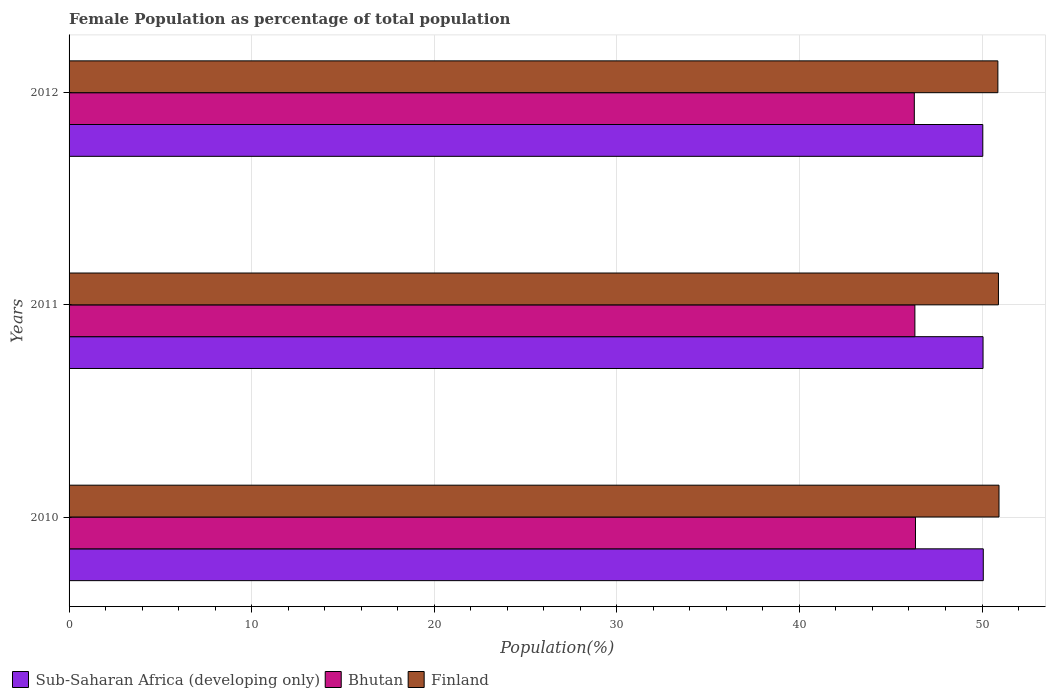How many groups of bars are there?
Offer a terse response. 3. Are the number of bars per tick equal to the number of legend labels?
Your response must be concise. Yes. Are the number of bars on each tick of the Y-axis equal?
Your answer should be compact. Yes. How many bars are there on the 2nd tick from the top?
Offer a terse response. 3. How many bars are there on the 1st tick from the bottom?
Offer a very short reply. 3. What is the label of the 3rd group of bars from the top?
Keep it short and to the point. 2010. What is the female population in in Bhutan in 2011?
Ensure brevity in your answer.  46.32. Across all years, what is the maximum female population in in Finland?
Provide a short and direct response. 50.93. Across all years, what is the minimum female population in in Finland?
Offer a terse response. 50.87. What is the total female population in in Bhutan in the graph?
Your response must be concise. 138.97. What is the difference between the female population in in Sub-Saharan Africa (developing only) in 2011 and that in 2012?
Provide a short and direct response. 0.01. What is the difference between the female population in in Finland in 2011 and the female population in in Sub-Saharan Africa (developing only) in 2012?
Ensure brevity in your answer.  0.86. What is the average female population in in Bhutan per year?
Provide a short and direct response. 46.32. In the year 2010, what is the difference between the female population in in Sub-Saharan Africa (developing only) and female population in in Finland?
Give a very brief answer. -0.86. In how many years, is the female population in in Bhutan greater than 16 %?
Give a very brief answer. 3. What is the ratio of the female population in in Finland in 2011 to that in 2012?
Make the answer very short. 1. Is the female population in in Sub-Saharan Africa (developing only) in 2011 less than that in 2012?
Keep it short and to the point. No. What is the difference between the highest and the second highest female population in in Bhutan?
Ensure brevity in your answer.  0.03. What is the difference between the highest and the lowest female population in in Bhutan?
Your response must be concise. 0.06. Is the sum of the female population in in Bhutan in 2010 and 2012 greater than the maximum female population in in Finland across all years?
Provide a succinct answer. Yes. What does the 3rd bar from the top in 2012 represents?
Your answer should be compact. Sub-Saharan Africa (developing only). What does the 1st bar from the bottom in 2010 represents?
Offer a very short reply. Sub-Saharan Africa (developing only). Is it the case that in every year, the sum of the female population in in Finland and female population in in Sub-Saharan Africa (developing only) is greater than the female population in in Bhutan?
Your answer should be very brief. Yes. Are all the bars in the graph horizontal?
Make the answer very short. Yes. What is the difference between two consecutive major ticks on the X-axis?
Your answer should be compact. 10. Does the graph contain any zero values?
Provide a short and direct response. No. Where does the legend appear in the graph?
Provide a succinct answer. Bottom left. What is the title of the graph?
Keep it short and to the point. Female Population as percentage of total population. What is the label or title of the X-axis?
Your answer should be compact. Population(%). What is the label or title of the Y-axis?
Your answer should be very brief. Years. What is the Population(%) in Sub-Saharan Africa (developing only) in 2010?
Offer a terse response. 50.07. What is the Population(%) of Bhutan in 2010?
Offer a very short reply. 46.36. What is the Population(%) of Finland in 2010?
Offer a terse response. 50.93. What is the Population(%) in Sub-Saharan Africa (developing only) in 2011?
Give a very brief answer. 50.06. What is the Population(%) in Bhutan in 2011?
Your answer should be very brief. 46.32. What is the Population(%) of Finland in 2011?
Ensure brevity in your answer.  50.9. What is the Population(%) in Sub-Saharan Africa (developing only) in 2012?
Your response must be concise. 50.04. What is the Population(%) of Bhutan in 2012?
Your answer should be very brief. 46.29. What is the Population(%) in Finland in 2012?
Keep it short and to the point. 50.87. Across all years, what is the maximum Population(%) of Sub-Saharan Africa (developing only)?
Offer a very short reply. 50.07. Across all years, what is the maximum Population(%) of Bhutan?
Provide a succinct answer. 46.36. Across all years, what is the maximum Population(%) of Finland?
Your answer should be very brief. 50.93. Across all years, what is the minimum Population(%) in Sub-Saharan Africa (developing only)?
Your response must be concise. 50.04. Across all years, what is the minimum Population(%) of Bhutan?
Offer a very short reply. 46.29. Across all years, what is the minimum Population(%) in Finland?
Offer a very short reply. 50.87. What is the total Population(%) of Sub-Saharan Africa (developing only) in the graph?
Provide a succinct answer. 150.17. What is the total Population(%) of Bhutan in the graph?
Give a very brief answer. 138.97. What is the total Population(%) in Finland in the graph?
Offer a very short reply. 152.7. What is the difference between the Population(%) in Sub-Saharan Africa (developing only) in 2010 and that in 2011?
Offer a terse response. 0.01. What is the difference between the Population(%) of Bhutan in 2010 and that in 2011?
Your answer should be very brief. 0.03. What is the difference between the Population(%) of Finland in 2010 and that in 2011?
Your answer should be very brief. 0.03. What is the difference between the Population(%) of Sub-Saharan Africa (developing only) in 2010 and that in 2012?
Ensure brevity in your answer.  0.03. What is the difference between the Population(%) in Bhutan in 2010 and that in 2012?
Your answer should be compact. 0.06. What is the difference between the Population(%) in Finland in 2010 and that in 2012?
Offer a terse response. 0.06. What is the difference between the Population(%) in Sub-Saharan Africa (developing only) in 2011 and that in 2012?
Your answer should be compact. 0.01. What is the difference between the Population(%) of Bhutan in 2011 and that in 2012?
Offer a terse response. 0.03. What is the difference between the Population(%) in Finland in 2011 and that in 2012?
Your answer should be very brief. 0.03. What is the difference between the Population(%) of Sub-Saharan Africa (developing only) in 2010 and the Population(%) of Bhutan in 2011?
Ensure brevity in your answer.  3.75. What is the difference between the Population(%) in Sub-Saharan Africa (developing only) in 2010 and the Population(%) in Finland in 2011?
Offer a very short reply. -0.83. What is the difference between the Population(%) of Bhutan in 2010 and the Population(%) of Finland in 2011?
Ensure brevity in your answer.  -4.54. What is the difference between the Population(%) of Sub-Saharan Africa (developing only) in 2010 and the Population(%) of Bhutan in 2012?
Keep it short and to the point. 3.78. What is the difference between the Population(%) in Sub-Saharan Africa (developing only) in 2010 and the Population(%) in Finland in 2012?
Your answer should be very brief. -0.8. What is the difference between the Population(%) in Bhutan in 2010 and the Population(%) in Finland in 2012?
Ensure brevity in your answer.  -4.51. What is the difference between the Population(%) in Sub-Saharan Africa (developing only) in 2011 and the Population(%) in Bhutan in 2012?
Your answer should be compact. 3.76. What is the difference between the Population(%) in Sub-Saharan Africa (developing only) in 2011 and the Population(%) in Finland in 2012?
Make the answer very short. -0.81. What is the difference between the Population(%) in Bhutan in 2011 and the Population(%) in Finland in 2012?
Your answer should be compact. -4.54. What is the average Population(%) of Sub-Saharan Africa (developing only) per year?
Make the answer very short. 50.06. What is the average Population(%) in Bhutan per year?
Offer a terse response. 46.32. What is the average Population(%) of Finland per year?
Your response must be concise. 50.9. In the year 2010, what is the difference between the Population(%) of Sub-Saharan Africa (developing only) and Population(%) of Bhutan?
Ensure brevity in your answer.  3.71. In the year 2010, what is the difference between the Population(%) in Sub-Saharan Africa (developing only) and Population(%) in Finland?
Give a very brief answer. -0.86. In the year 2010, what is the difference between the Population(%) of Bhutan and Population(%) of Finland?
Provide a succinct answer. -4.57. In the year 2011, what is the difference between the Population(%) of Sub-Saharan Africa (developing only) and Population(%) of Bhutan?
Keep it short and to the point. 3.73. In the year 2011, what is the difference between the Population(%) in Sub-Saharan Africa (developing only) and Population(%) in Finland?
Offer a very short reply. -0.84. In the year 2011, what is the difference between the Population(%) in Bhutan and Population(%) in Finland?
Provide a succinct answer. -4.58. In the year 2012, what is the difference between the Population(%) of Sub-Saharan Africa (developing only) and Population(%) of Bhutan?
Offer a very short reply. 3.75. In the year 2012, what is the difference between the Population(%) in Sub-Saharan Africa (developing only) and Population(%) in Finland?
Keep it short and to the point. -0.83. In the year 2012, what is the difference between the Population(%) of Bhutan and Population(%) of Finland?
Ensure brevity in your answer.  -4.58. What is the ratio of the Population(%) of Sub-Saharan Africa (developing only) in 2010 to that in 2011?
Your answer should be compact. 1. What is the ratio of the Population(%) in Bhutan in 2010 to that in 2011?
Your answer should be compact. 1. What is the ratio of the Population(%) of Finland in 2010 to that in 2011?
Your answer should be very brief. 1. What is the ratio of the Population(%) in Sub-Saharan Africa (developing only) in 2010 to that in 2012?
Offer a terse response. 1. What is the ratio of the Population(%) of Finland in 2011 to that in 2012?
Provide a short and direct response. 1. What is the difference between the highest and the second highest Population(%) of Sub-Saharan Africa (developing only)?
Offer a terse response. 0.01. What is the difference between the highest and the second highest Population(%) of Bhutan?
Provide a short and direct response. 0.03. What is the difference between the highest and the second highest Population(%) in Finland?
Your answer should be compact. 0.03. What is the difference between the highest and the lowest Population(%) of Sub-Saharan Africa (developing only)?
Ensure brevity in your answer.  0.03. What is the difference between the highest and the lowest Population(%) in Bhutan?
Your answer should be compact. 0.06. What is the difference between the highest and the lowest Population(%) of Finland?
Ensure brevity in your answer.  0.06. 